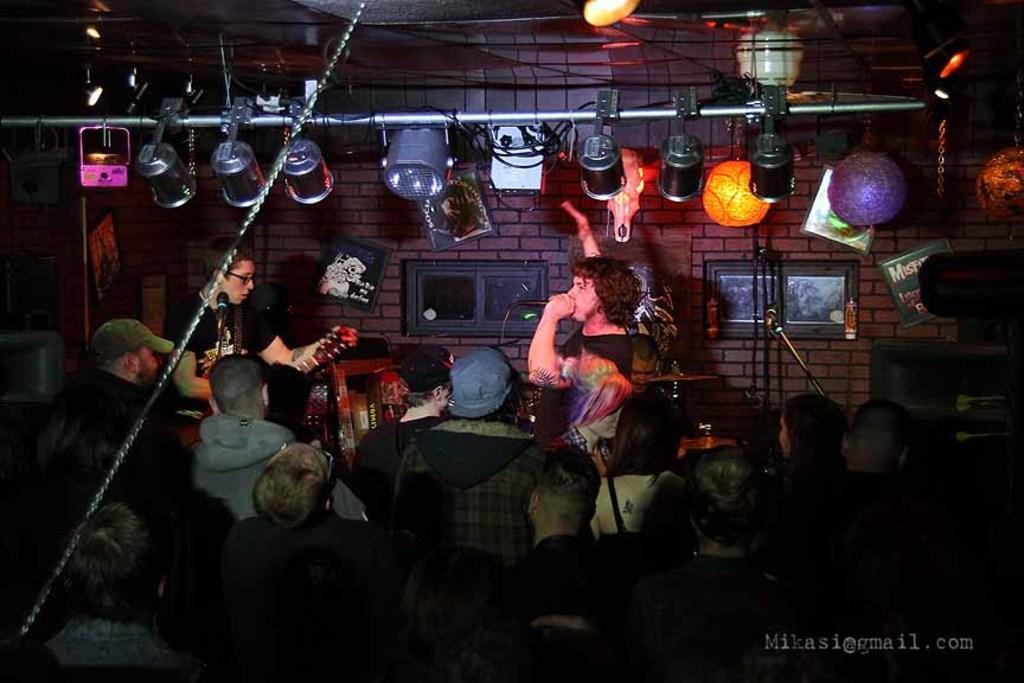Describe this image in one or two sentences. There are many persons standing there. And one person wearing a black dress is holding a mic and singing. Another person is holding a guitar and playing. In the background there is a brick wall. And there are some photo frames. And there is a light. There are hanging bulbs. 